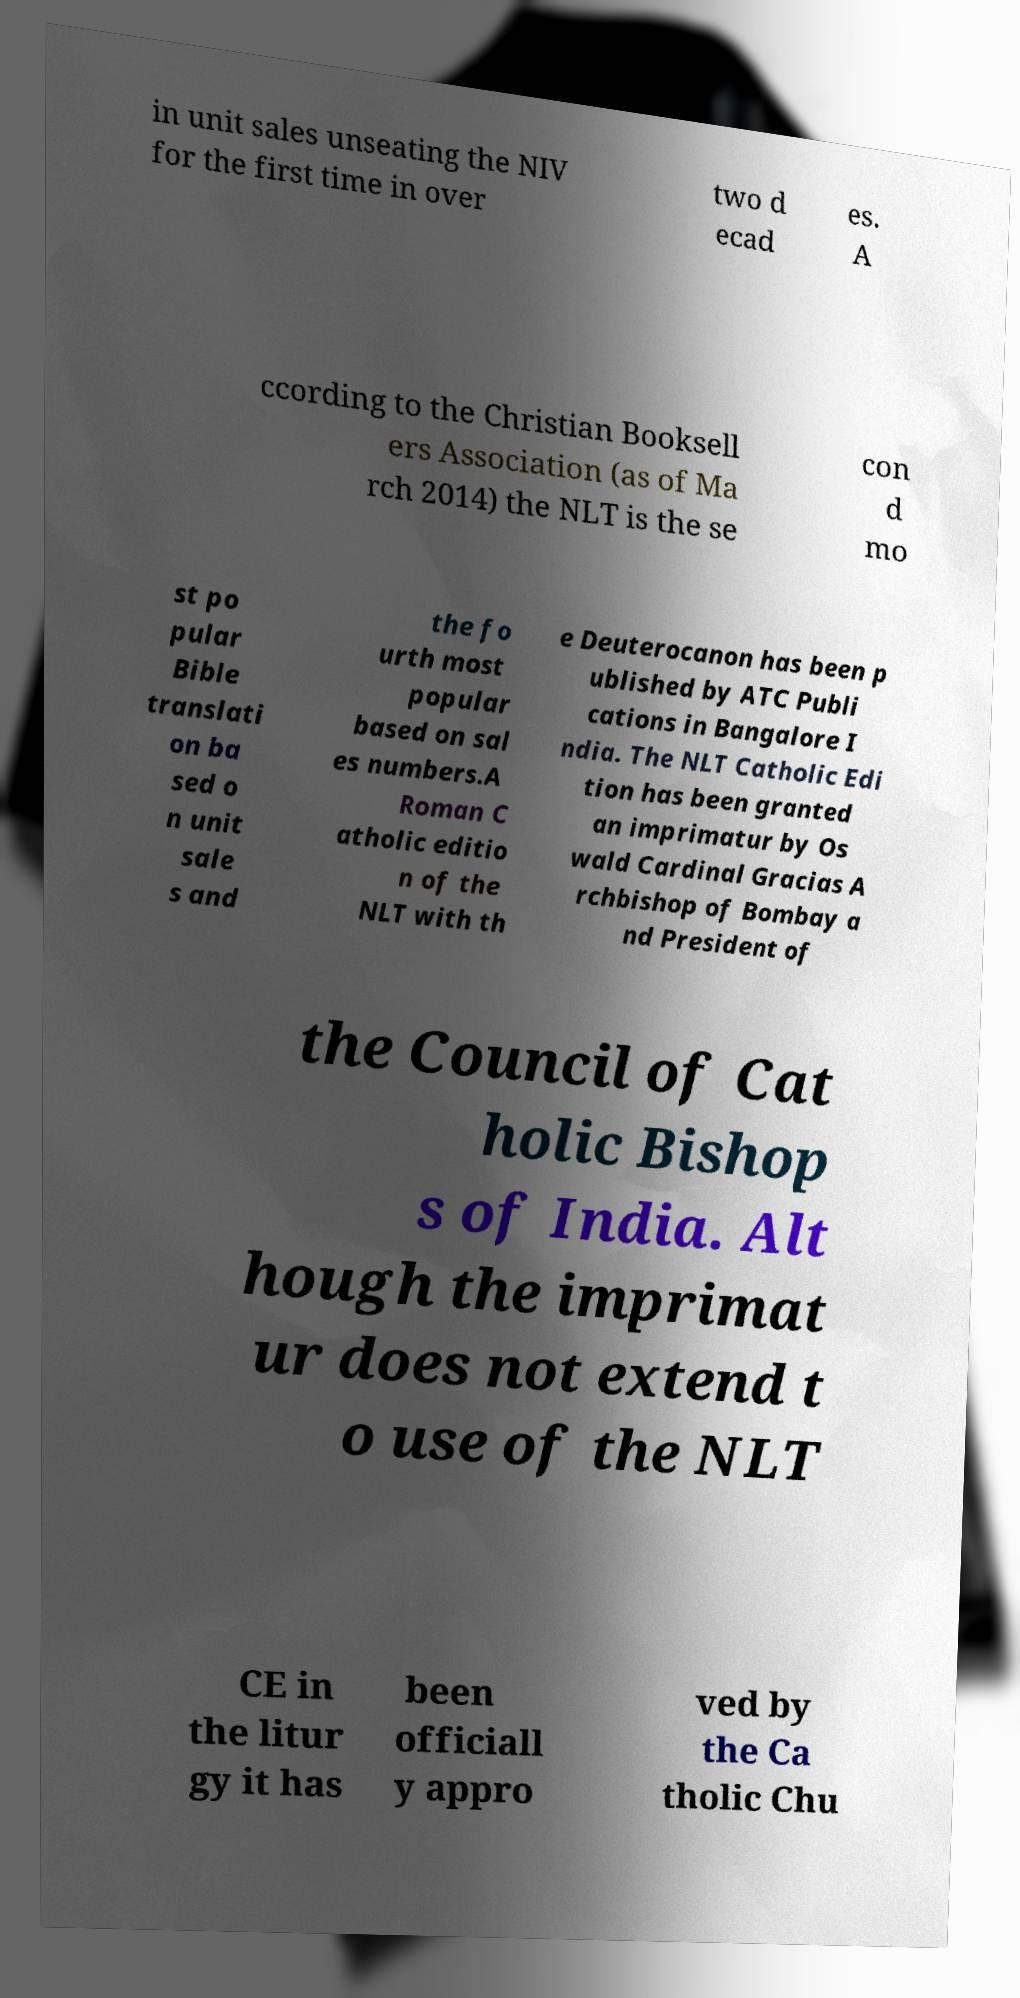Please identify and transcribe the text found in this image. in unit sales unseating the NIV for the first time in over two d ecad es. A ccording to the Christian Booksell ers Association (as of Ma rch 2014) the NLT is the se con d mo st po pular Bible translati on ba sed o n unit sale s and the fo urth most popular based on sal es numbers.A Roman C atholic editio n of the NLT with th e Deuterocanon has been p ublished by ATC Publi cations in Bangalore I ndia. The NLT Catholic Edi tion has been granted an imprimatur by Os wald Cardinal Gracias A rchbishop of Bombay a nd President of the Council of Cat holic Bishop s of India. Alt hough the imprimat ur does not extend t o use of the NLT CE in the litur gy it has been officiall y appro ved by the Ca tholic Chu 